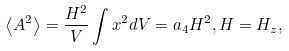Convert formula to latex. <formula><loc_0><loc_0><loc_500><loc_500>\left \langle A ^ { 2 } \right \rangle = \frac { H ^ { 2 } } { V } \int x ^ { 2 } d V = a _ { 4 } H ^ { 2 } , H = H _ { z } ,</formula> 